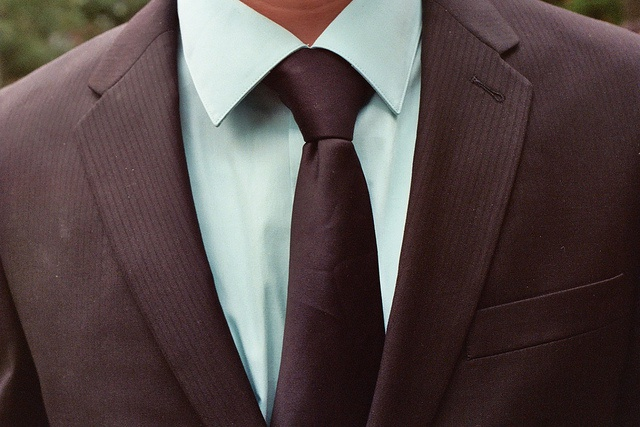Describe the objects in this image and their specific colors. I can see people in black, gray, lightgray, and olive tones and tie in olive, black, purple, and gray tones in this image. 